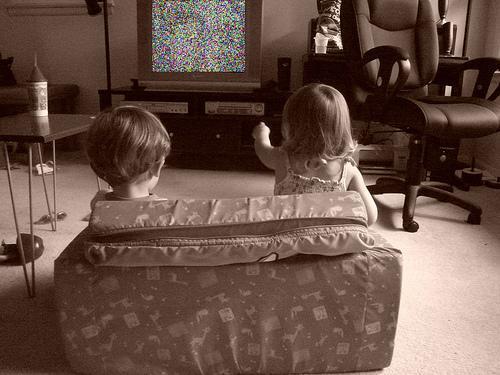How many kids are sitting down?
Give a very brief answer. 2. How many chairs can you see?
Give a very brief answer. 3. How many people are visible?
Give a very brief answer. 2. How many giraffes are standing up?
Give a very brief answer. 0. 